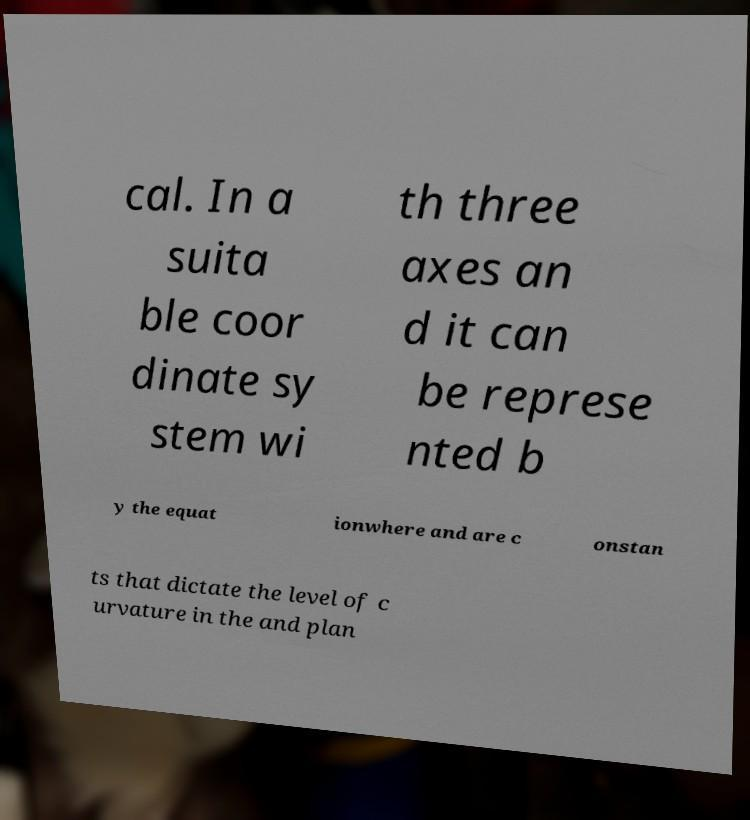Please identify and transcribe the text found in this image. cal. In a suita ble coor dinate sy stem wi th three axes an d it can be represe nted b y the equat ionwhere and are c onstan ts that dictate the level of c urvature in the and plan 